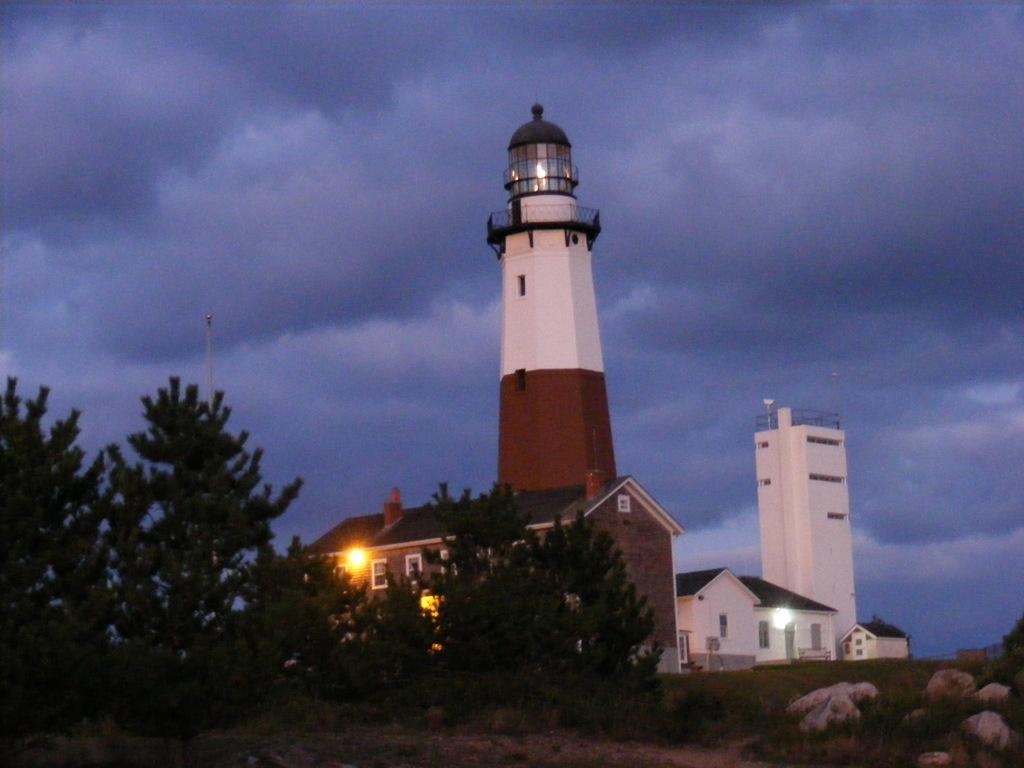Please provide a concise description of this image. This image is taken outdoors. At the top of the image there is the sky with clouds. At the bottom of the image there is the ground with grass on it and there are few a rocks on the ground. In the background there are a few houses. There is a tower. There is a building. On the left side of the image there are few trees. 